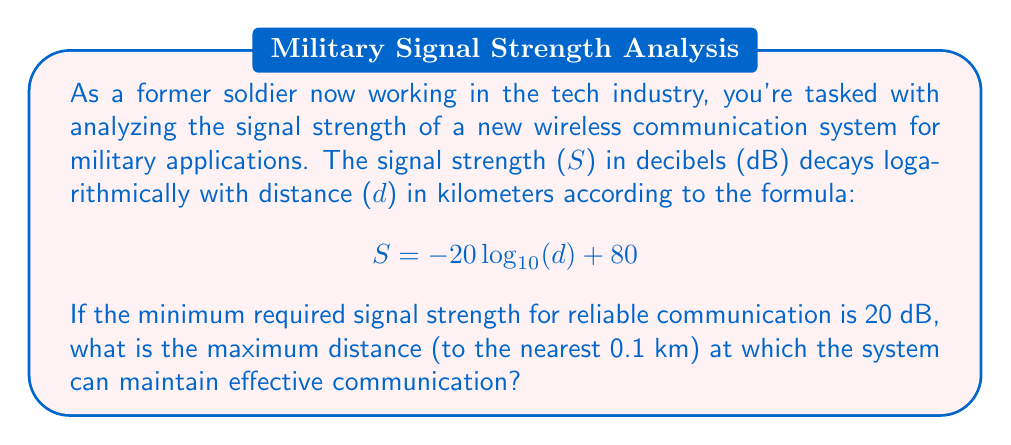Provide a solution to this math problem. To solve this problem, we need to use the given logarithmic function and solve for d when S = 20 dB. Let's approach this step-by-step:

1) We start with the equation:
   $$ S = -20 \log_{10}(d) + 80 $$

2) We know that S = 20 dB at the maximum distance. Let's substitute this:
   $$ 20 = -20 \log_{10}(d) + 80 $$

3) Subtract 80 from both sides:
   $$ -60 = -20 \log_{10}(d) $$

4) Divide both sides by -20:
   $$ 3 = \log_{10}(d) $$

5) To solve for d, we need to apply the inverse function of $\log_{10}$, which is $10^x$:
   $$ d = 10^3 = 1000 $$

6) Therefore, the maximum distance is 1000 km.

To verify:
$$ S = -20 \log_{10}(1000) + 80 = -20(3) + 80 = -60 + 80 = 20 \text{ dB} $$

This confirms our calculation is correct.
Answer: The maximum distance at which the system can maintain effective communication is 1000.0 km. 